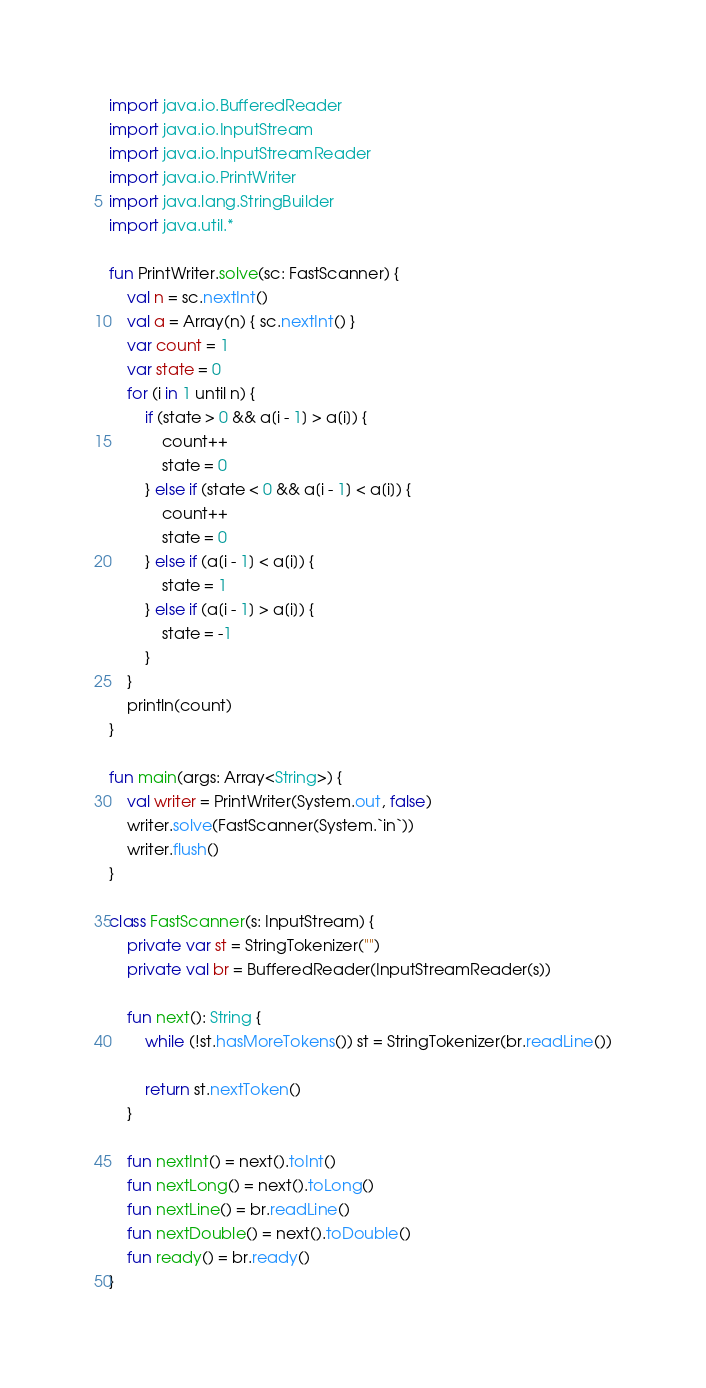<code> <loc_0><loc_0><loc_500><loc_500><_Kotlin_>import java.io.BufferedReader
import java.io.InputStream
import java.io.InputStreamReader
import java.io.PrintWriter
import java.lang.StringBuilder
import java.util.*

fun PrintWriter.solve(sc: FastScanner) {
    val n = sc.nextInt()
    val a = Array(n) { sc.nextInt() }
    var count = 1
    var state = 0
    for (i in 1 until n) {
        if (state > 0 && a[i - 1] > a[i]) {
            count++
            state = 0
        } else if (state < 0 && a[i - 1] < a[i]) {
            count++
            state = 0
        } else if (a[i - 1] < a[i]) {
            state = 1
        } else if (a[i - 1] > a[i]) {
            state = -1
        }
    }
    println(count)
}

fun main(args: Array<String>) {
    val writer = PrintWriter(System.out, false)
    writer.solve(FastScanner(System.`in`))
    writer.flush()
}

class FastScanner(s: InputStream) {
    private var st = StringTokenizer("")
    private val br = BufferedReader(InputStreamReader(s))

    fun next(): String {
        while (!st.hasMoreTokens()) st = StringTokenizer(br.readLine())

        return st.nextToken()
    }

    fun nextInt() = next().toInt()
    fun nextLong() = next().toLong()
    fun nextLine() = br.readLine()
    fun nextDouble() = next().toDouble()
    fun ready() = br.ready()
}
</code> 